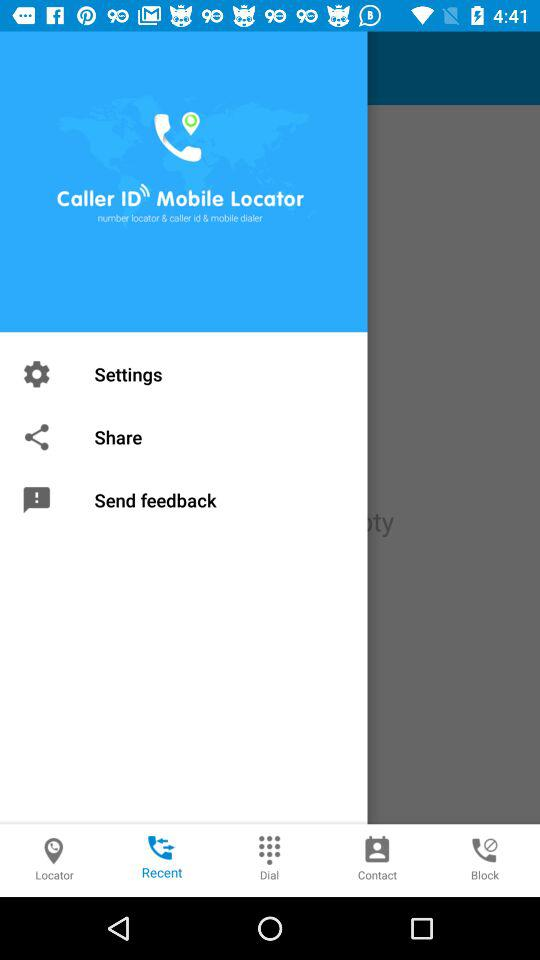How many notifications are there in "Settings"?
When the provided information is insufficient, respond with <no answer>. <no answer> 